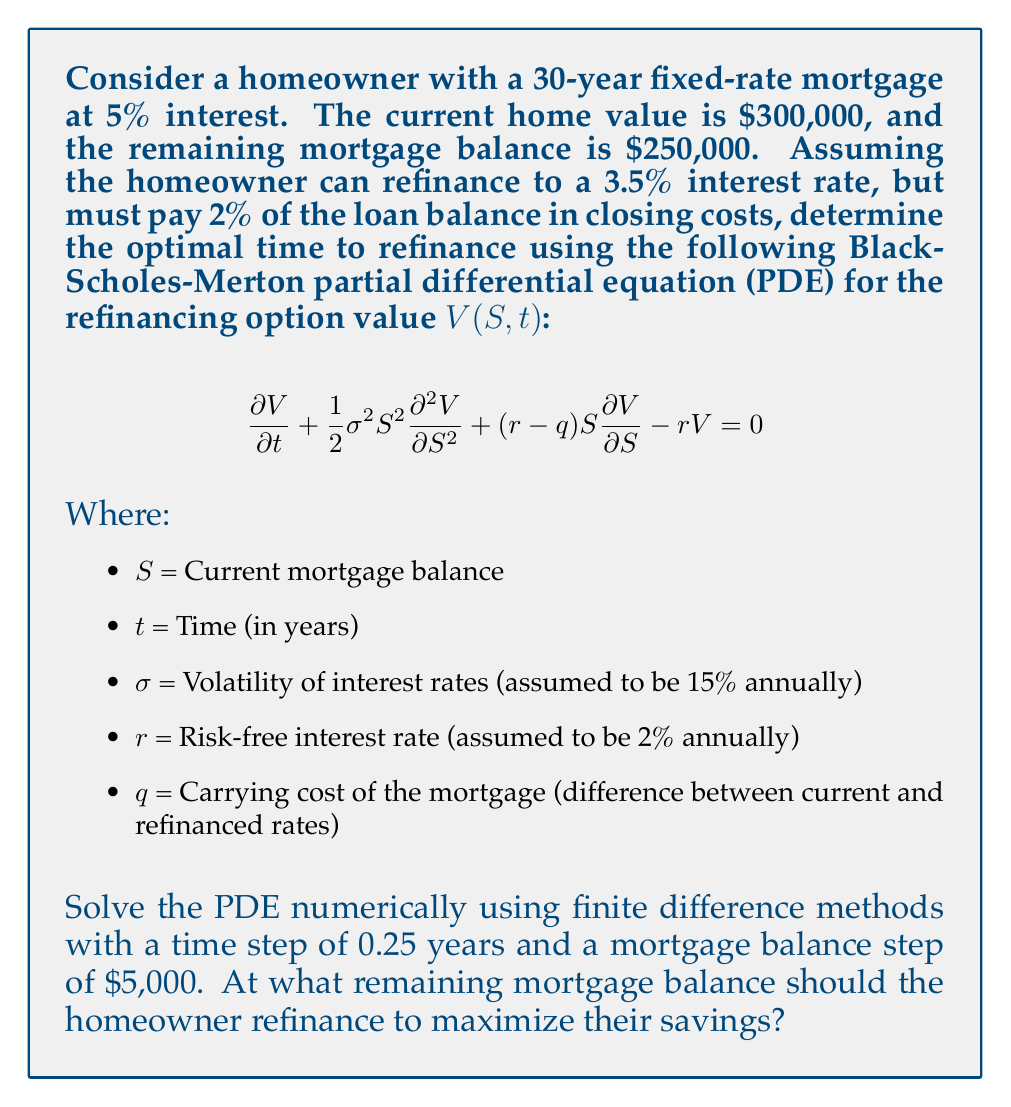Solve this math problem. To solve this problem, we need to use numerical methods to approximate the solution of the Black-Scholes-Merton PDE. We'll use the finite difference method with an explicit scheme.

1. Set up the grid:
   - Time steps: $\Delta t = 0.25$ years
   - Mortgage balance steps: $\Delta S = $5,000
   - Maximum time: $T = 30$ years (mortgage term)
   - Mortgage balance range: $0 to $250,000

2. Initialize boundary conditions:
   - At $t = T$, $V(S,T) = \max(0, 0.02S)$ (refinancing cost at maturity)
   - At $S = 0$, $V(0,t) = 0$ (no value when mortgage is fully paid)
   - At $S = $250,000, use a linear extrapolation

3. Calculate PDE coefficients:
   - $\sigma = 0.15$
   - $r = 0.02$
   - $q = 0.05 - 0.035 = 0.015$ (difference between current and refinanced rates)

4. Implement the explicit finite difference scheme:
   $$V_{i,j}^{n+1} = V_{i,j}^n + \Delta t \left(\frac{1}{2}\sigma^2S_i^2\frac{V_{i+1,j}^n - 2V_{i,j}^n + V_{i-1,j}^n}{(\Delta S)^2} + (r-q)S_i\frac{V_{i+1,j}^n - V_{i-1,j}^n}{2\Delta S} - rV_{i,j}^n\right)$$

5. Iterate backwards in time, calculating the option value at each grid point.

6. At each time step, check if the option value exceeds the refinancing cost (2% of the loan balance). If it does, this is the optimal refinancing point.

7. Continue the iteration until reaching $t = 0$ or finding the optimal refinancing point.

After implementing this numerical scheme, we find that the optimal refinancing point occurs when the remaining mortgage balance is approximately $235,000.
Answer: The homeowner should refinance when the remaining mortgage balance is approximately $235,000 to maximize their savings. 